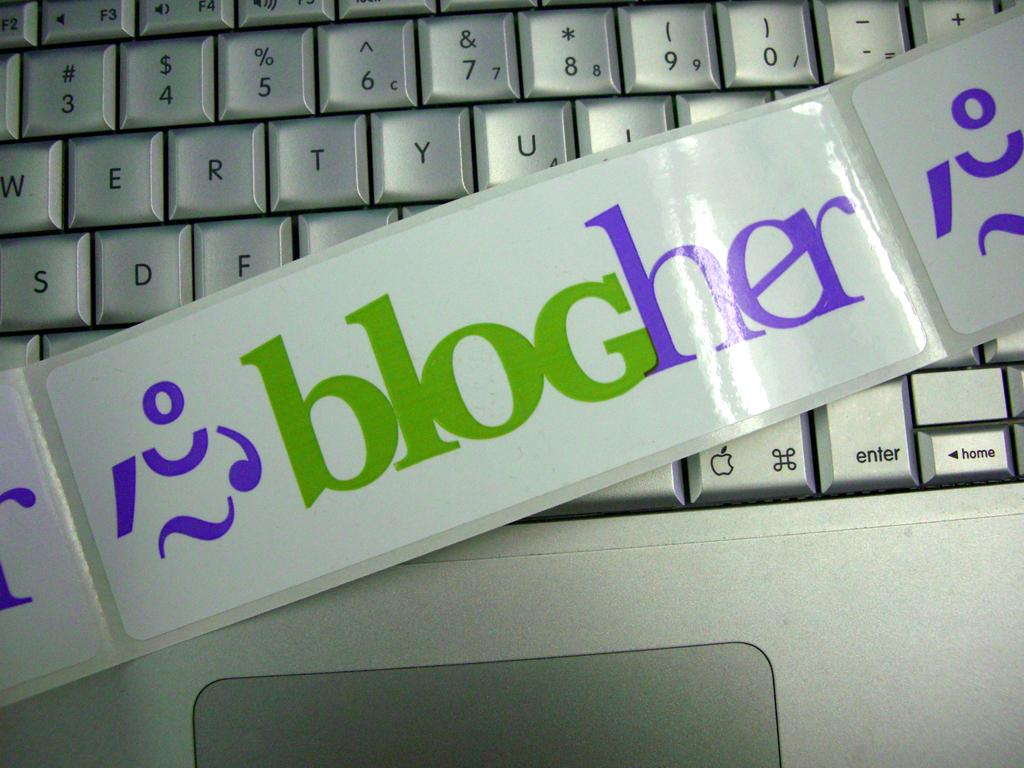What is the main object in the image? There is a keypad in the image. What else can be seen in the image besides the keypad? There are stickers with text in the image. How does the keypad help the representative breathe in the image? There is no representative or breathing-related activity depicted in the image; it only features a keypad and stickers with text. 